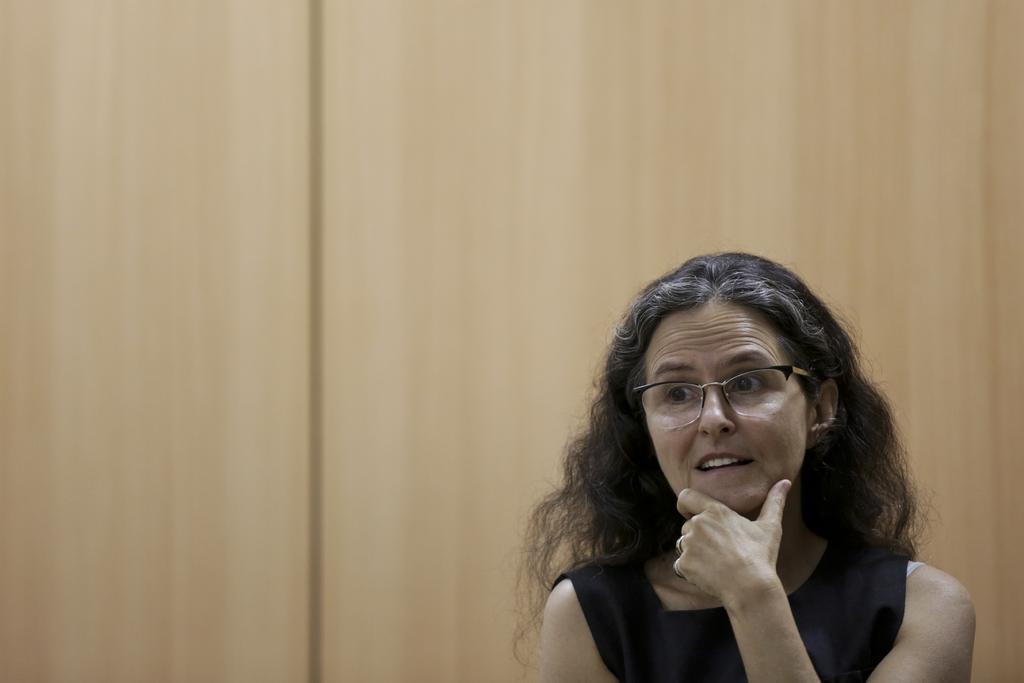Can you describe this image briefly? In this picture I can see a woman with spectacles, and in the background there is a wooden wall. 